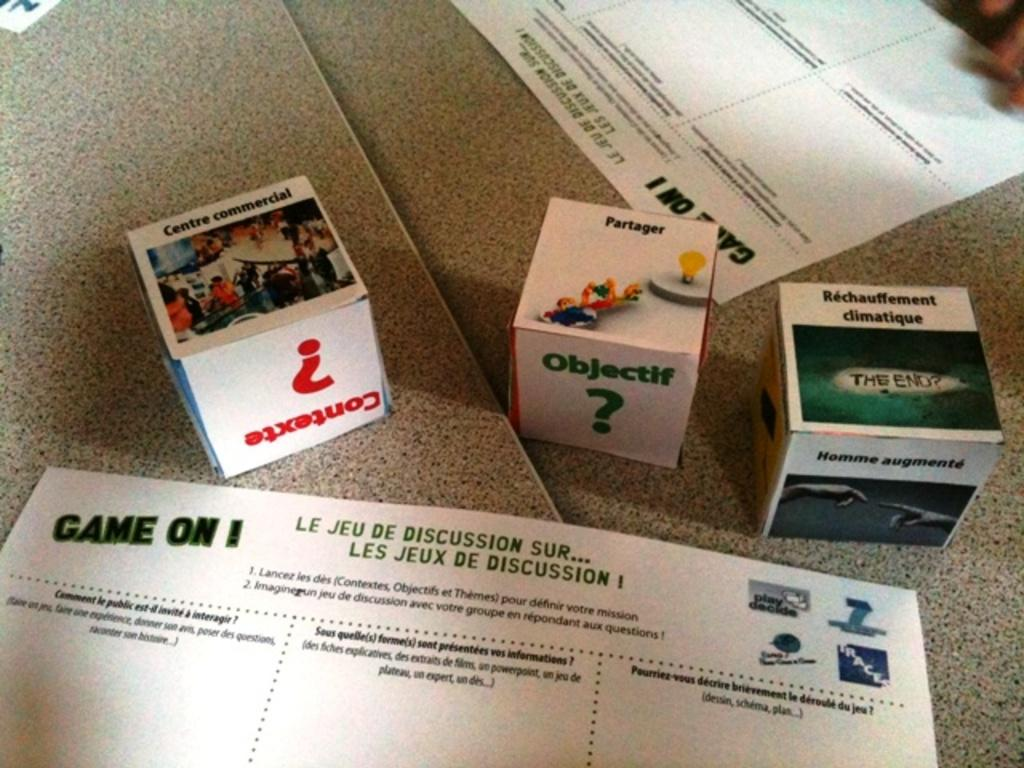Provide a one-sentence caption for the provided image. A game with three blocks in a foreign language. 